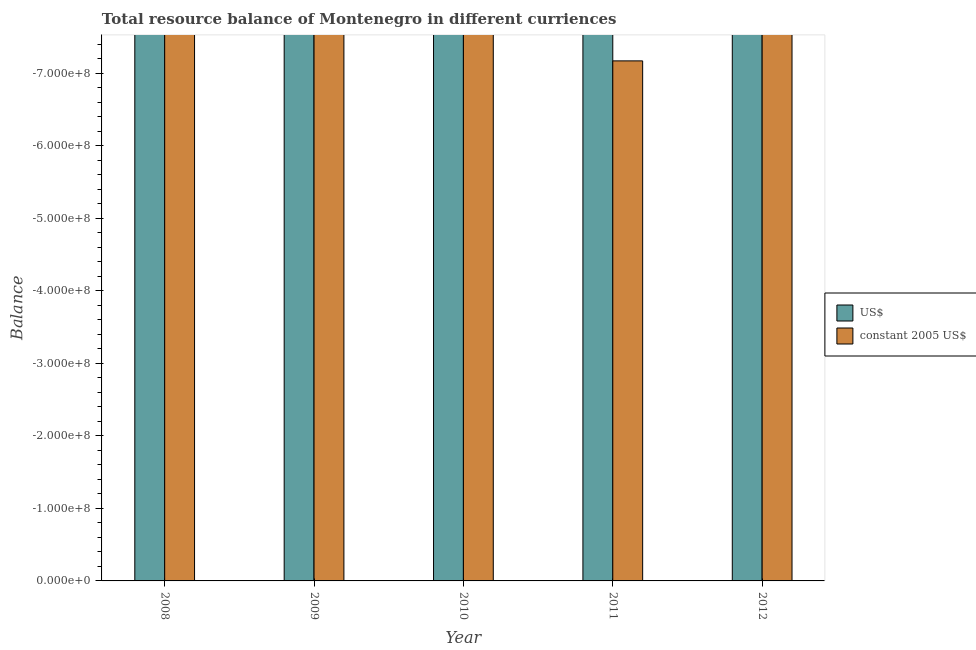How many bars are there on the 1st tick from the right?
Make the answer very short. 0. In how many cases, is the number of bars for a given year not equal to the number of legend labels?
Keep it short and to the point. 5. What is the resource balance in us$ in 2009?
Provide a succinct answer. 0. Across all years, what is the minimum resource balance in constant us$?
Your response must be concise. 0. In how many years, is the resource balance in us$ greater than -700000000 units?
Your answer should be very brief. 0. In how many years, is the resource balance in constant us$ greater than the average resource balance in constant us$ taken over all years?
Your answer should be very brief. 0. How many years are there in the graph?
Offer a very short reply. 5. Are the values on the major ticks of Y-axis written in scientific E-notation?
Provide a succinct answer. Yes. Does the graph contain grids?
Your answer should be compact. No. How many legend labels are there?
Your response must be concise. 2. What is the title of the graph?
Keep it short and to the point. Total resource balance of Montenegro in different curriences. Does "Primary income" appear as one of the legend labels in the graph?
Give a very brief answer. No. What is the label or title of the X-axis?
Offer a terse response. Year. What is the label or title of the Y-axis?
Provide a succinct answer. Balance. What is the Balance in constant 2005 US$ in 2008?
Your response must be concise. 0. What is the Balance of constant 2005 US$ in 2009?
Keep it short and to the point. 0. What is the Balance of constant 2005 US$ in 2010?
Your answer should be very brief. 0. What is the Balance in US$ in 2012?
Give a very brief answer. 0. What is the Balance in constant 2005 US$ in 2012?
Keep it short and to the point. 0. What is the total Balance of constant 2005 US$ in the graph?
Offer a terse response. 0. 